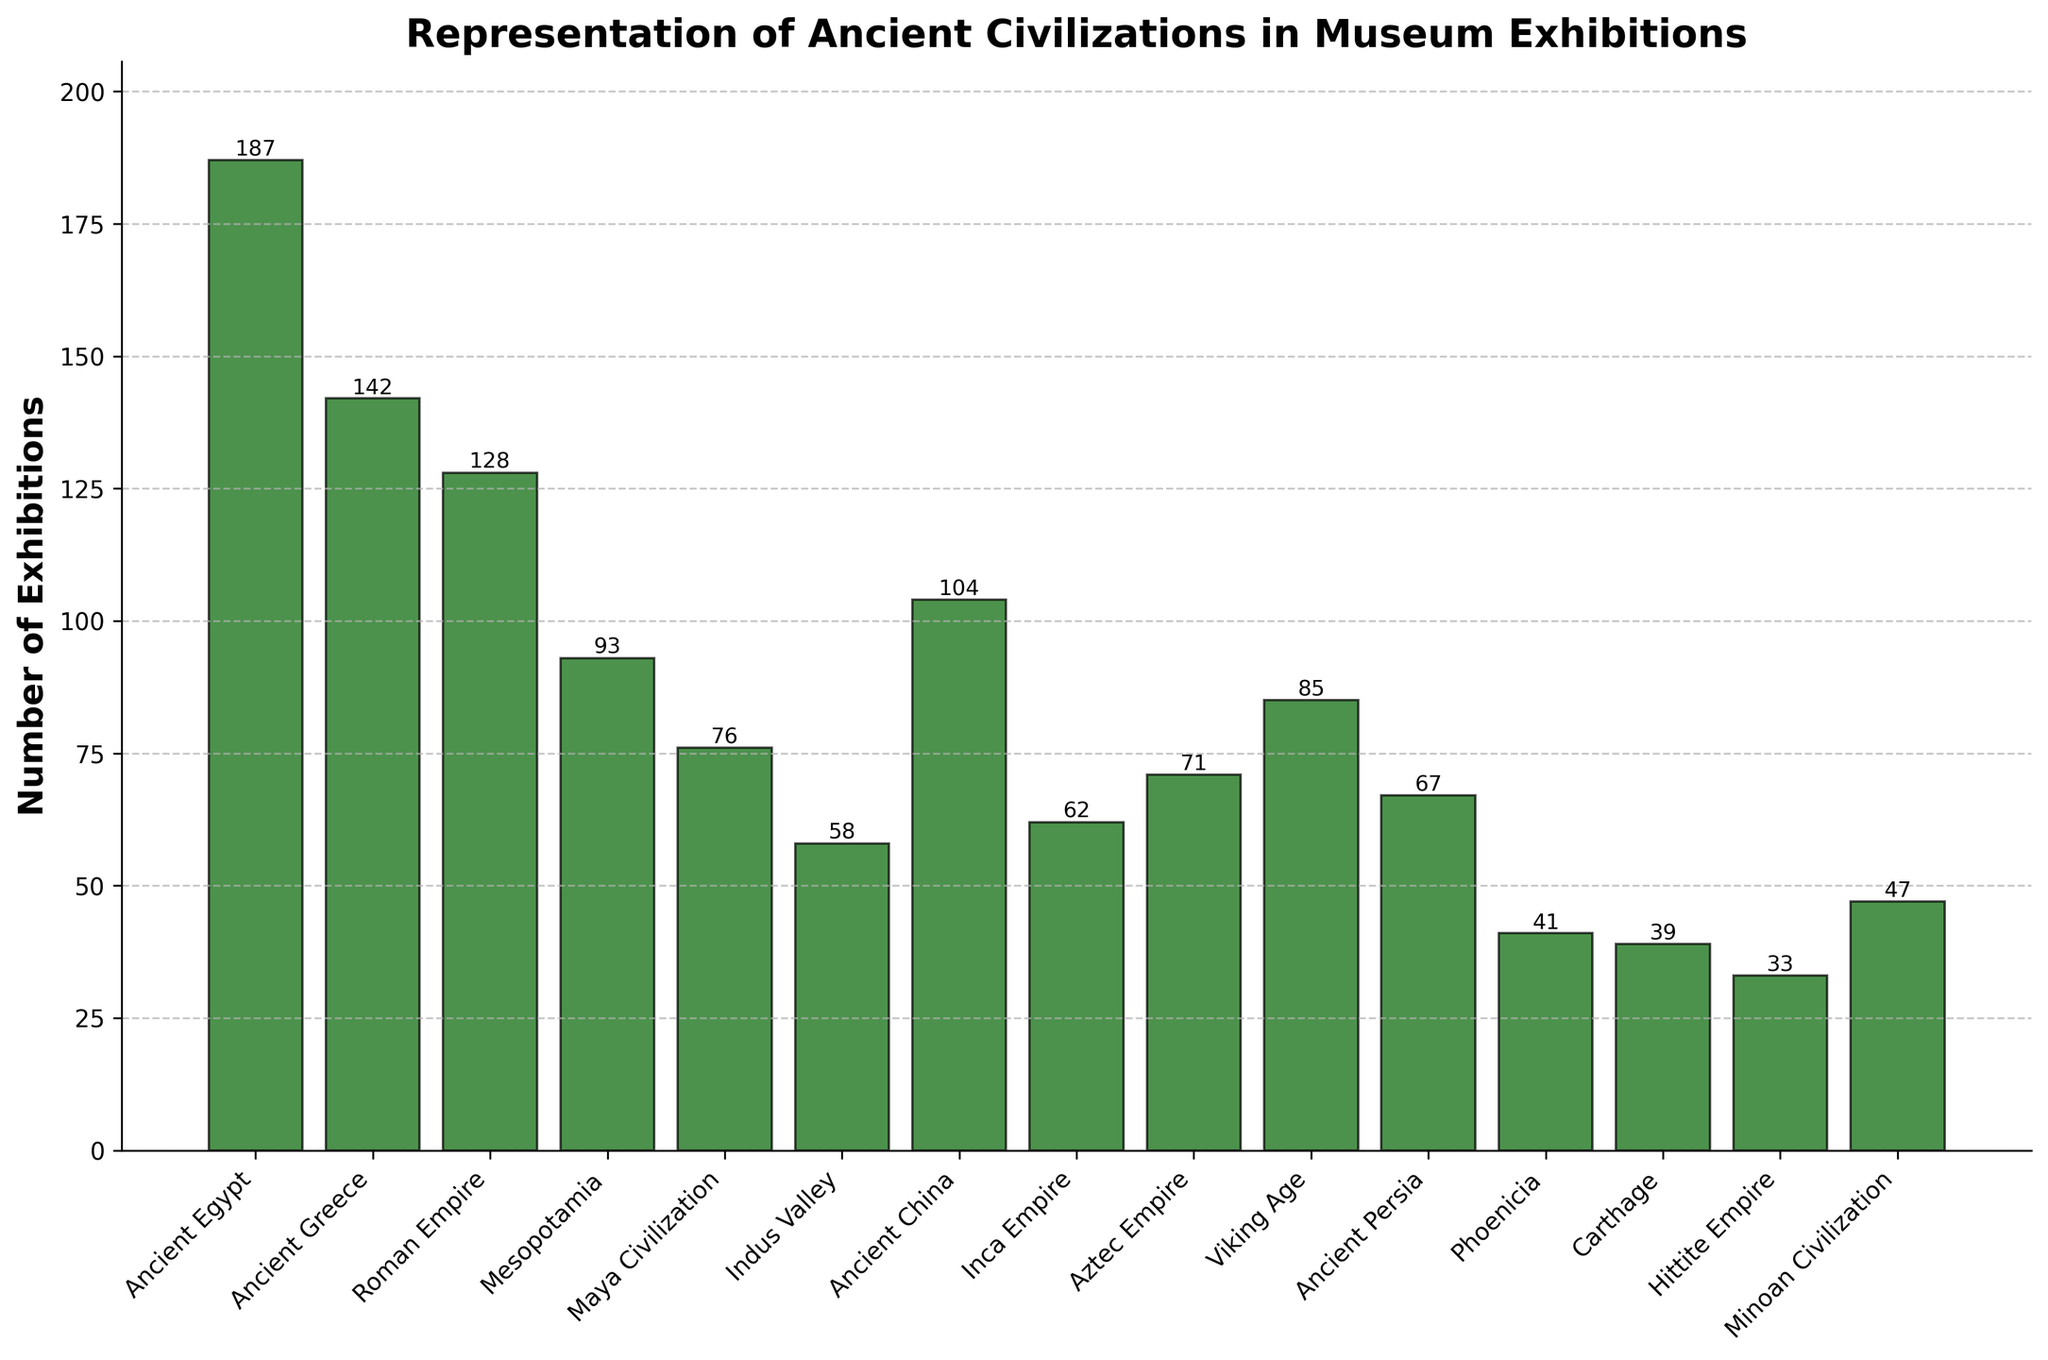Which civilization has the highest number of exhibitions? By observing the heights of the bars in the bar chart, Ancient Egypt's bar is the tallest. Its height indicates it has the highest number of exhibitions.
Answer: Ancient Egypt How many more exhibitions does Ancient Egypt have compared to the Aztec Empire? Ancient Egypt has 187 exhibitions and the Aztec Empire has 71 exhibitions. The difference is 187 - 71.
Answer: 116 What is the average number of exhibitions for Ancient Greece, Roman Empire, Mesopotamia, and Maya Civilization? The numbers of exhibitions are: Ancient Greece (142), Roman Empire (128), Mesopotamia (93), Maya Civilization (76). The sum is 142 + 128 + 93 + 76 = 439. There are 4 civilizations, thus the average is 439 / 4.
Answer: 109.75 Is Ancient China represented more frequently in exhibitions than the Inca Empire? By comparing the heights of the bars, Ancient China has 104 exhibitions while Inca Empire has 62 exhibitions. Since 104 > 62, Ancient China is represented more frequently.
Answer: Yes Which civilization has the lowest number of exhibitions? By looking at the shortest bar in the chart, the Hittite Empire's bar is the lowest, indicating it has the fewest exhibitions.
Answer: Hittite Empire What is the total number of exhibitions for the civilizations from Ancient Persia, Phoenicia, Carthage, and Minoan Civilization combined? The numbers of exhibitions are: Ancient Persia (67), Phoenicia (41), Carthage (39), Minoan Civilization (47). The total is 67 + 41 + 39 + 47.
Answer: 194 What is the difference in the number of exhibitions between Ancient Persia and Mesopotamia? Ancient Persia has 67 exhibitions and Mesopotamia has 93 exhibitions. The difference is 93 - 67.
Answer: 26 How many total exhibitions are accounted for by the top three civilizations with the most exhibitions? The top three civilizations are Ancient Egypt (187), Ancient Greece (142), and Roman Empire (128). The sum is 187 + 142 + 128.
Answer: 457 What is the median value of the number of exhibitions across all displayed civilizations? To find the median, list the number of exhibitions in ascending order: 33, 39, 41, 47, 58, 62, 67, 71, 76, 85, 93, 104, 128, 142, 187. There are 15 numbers, so the median is the 8th value in this list.
Answer: 71 